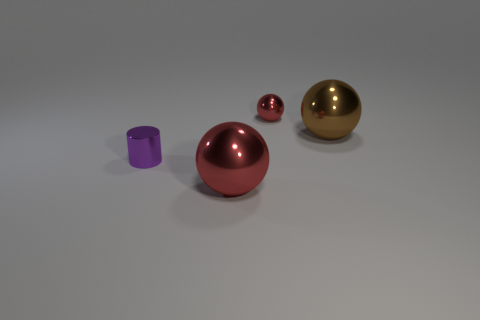Subtract all red spheres. How many spheres are left? 1 Subtract all red blocks. How many green cylinders are left? 0 Subtract all large brown balls. Subtract all metal spheres. How many objects are left? 0 Add 3 tiny metal cylinders. How many tiny metal cylinders are left? 4 Add 2 small red metal objects. How many small red metal objects exist? 3 Add 1 large red shiny things. How many objects exist? 5 Subtract all red spheres. How many spheres are left? 1 Subtract 0 green cubes. How many objects are left? 4 Subtract all balls. How many objects are left? 1 Subtract 1 cylinders. How many cylinders are left? 0 